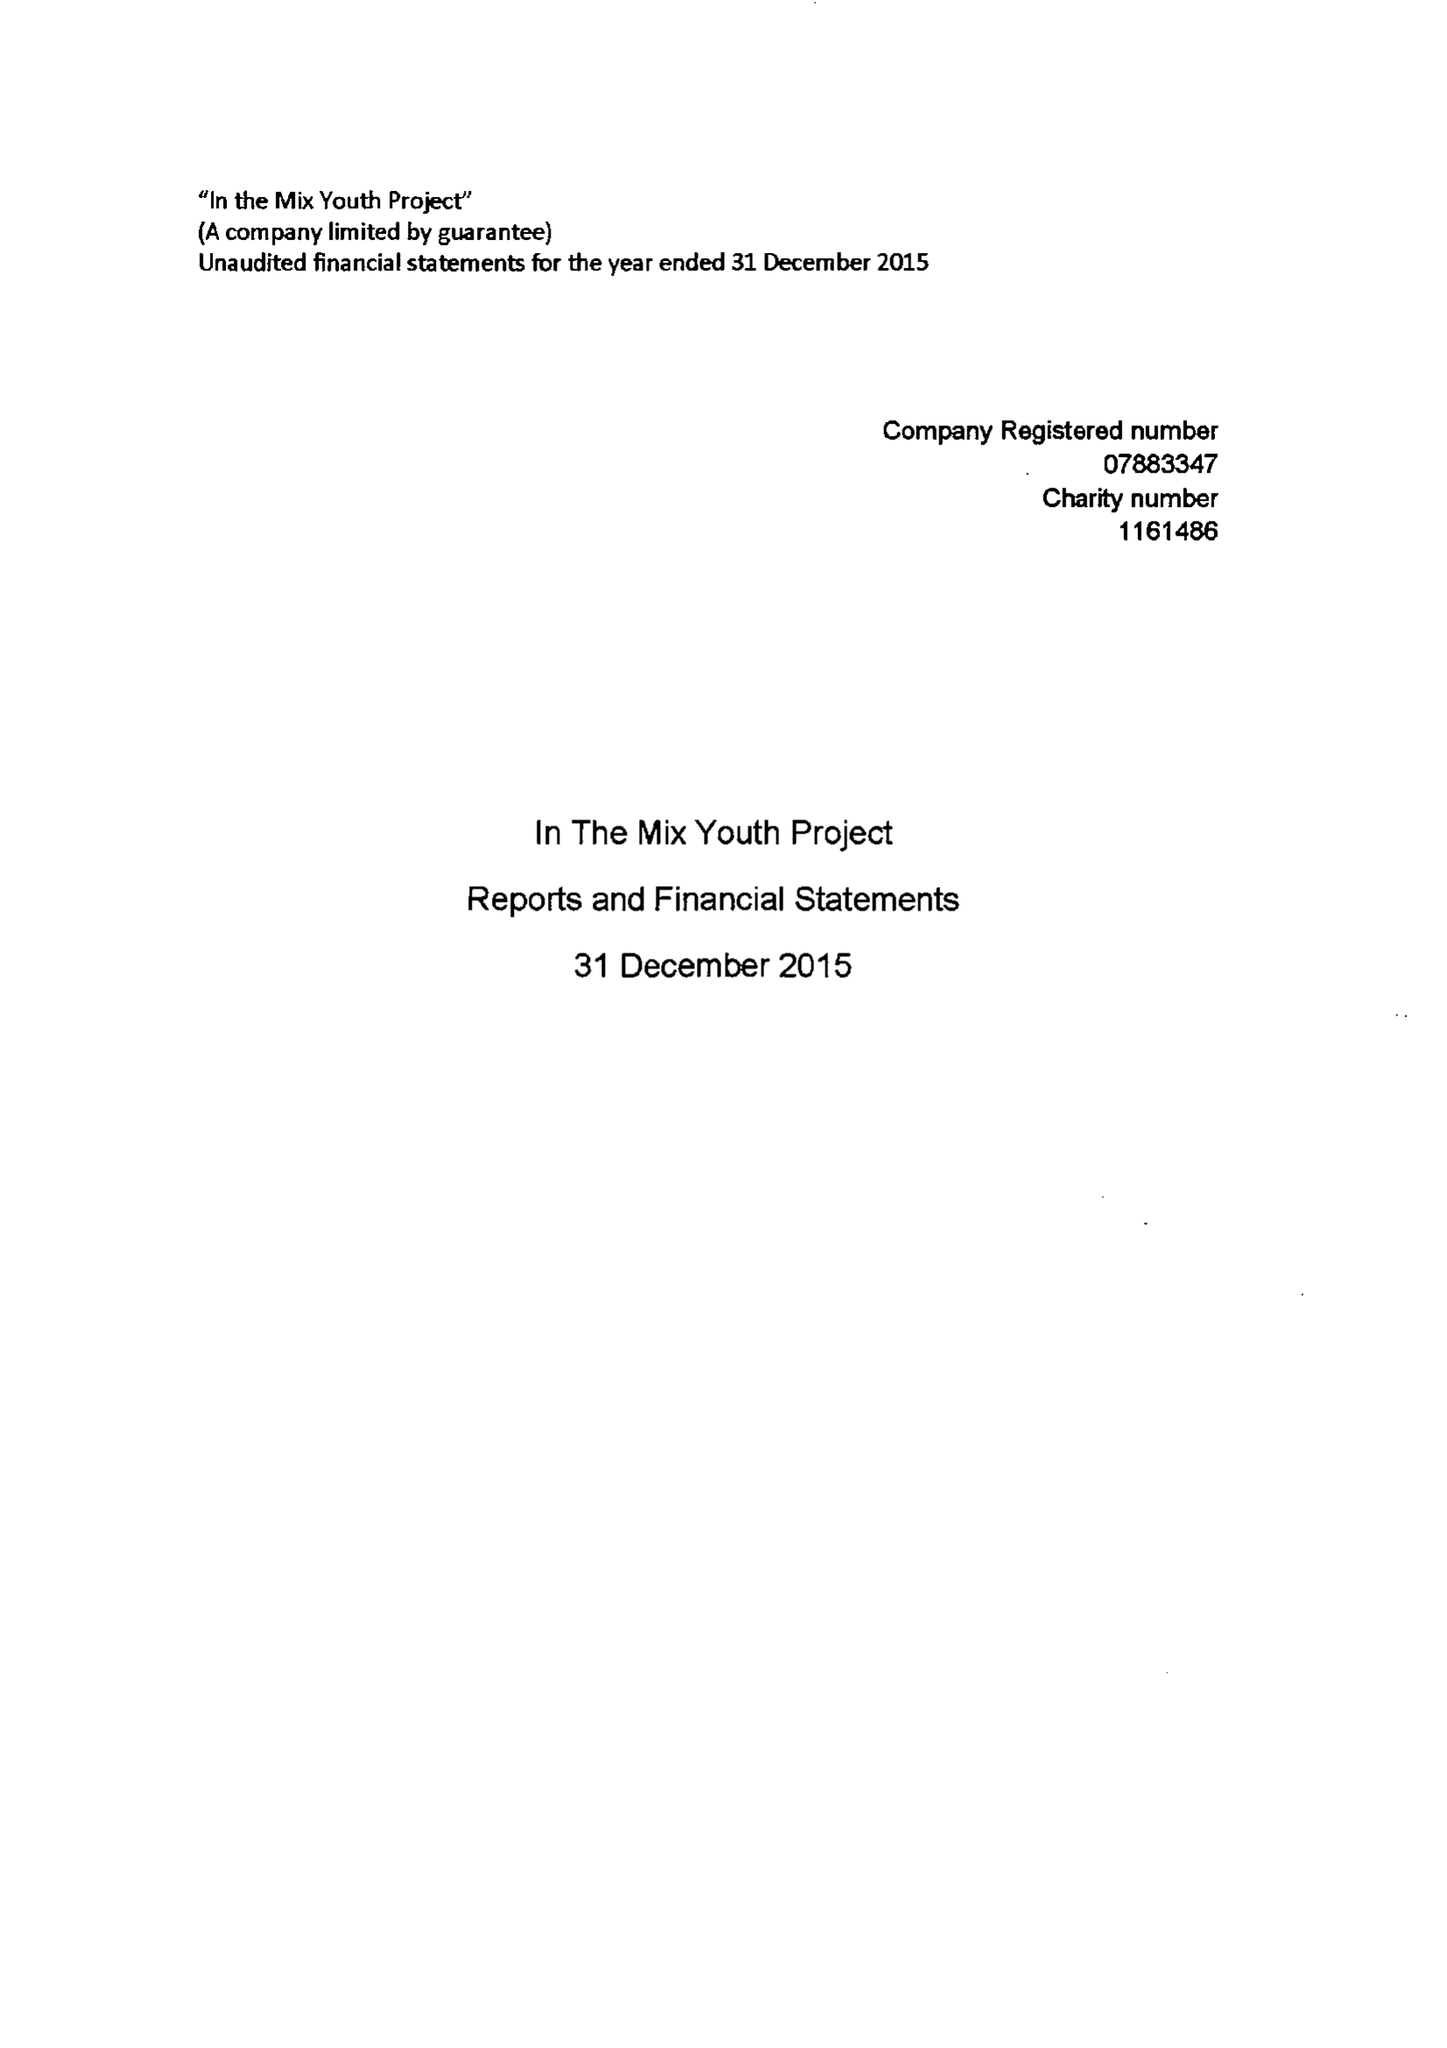What is the value for the report_date?
Answer the question using a single word or phrase. 2015-12-31 